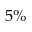<formula> <loc_0><loc_0><loc_500><loc_500>5 \%</formula> 